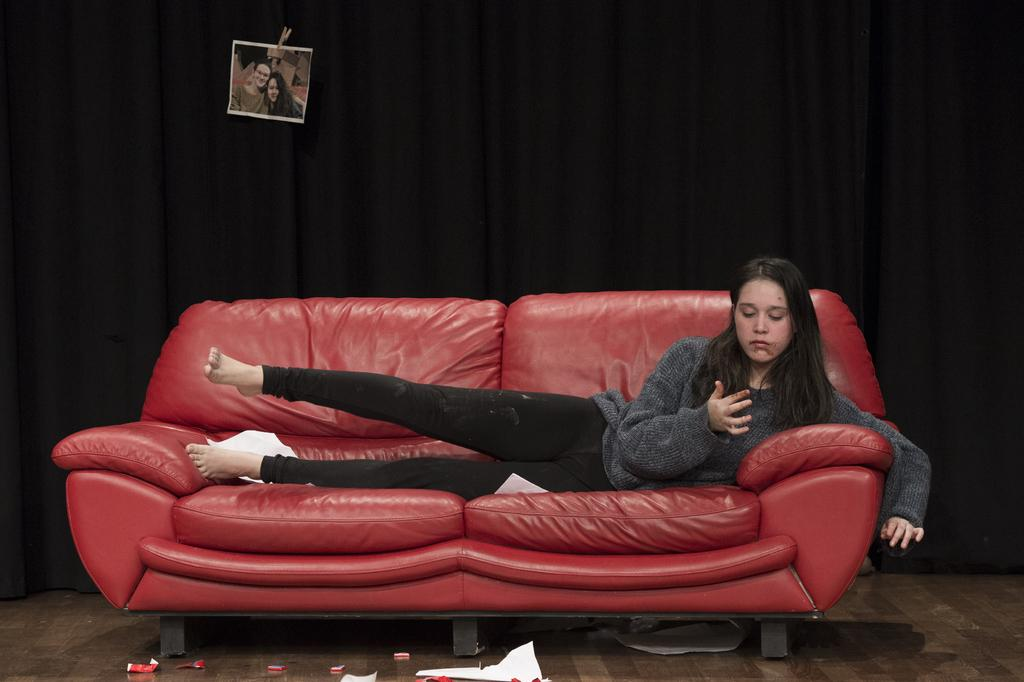Who is present in the image? There is a woman in the image. What is the woman wearing? The woman is wearing black pants. Where is the woman located in the image? The woman is sleeping on a red sofa. What is the woman doing in the image? The woman is looking at her hand. What can be seen in the background of the image? There is a black curtain in the background, and a photo is attached to it. What type of kite is the woman flying in the image? There is no kite present in the image; the woman is sleeping on a red sofa and looking at her hand. How does the woman's belief in skateboarding influence her actions in the image? There is no mention of skateboarding or any beliefs in the image, so it is not possible to determine how they might influence her actions. 